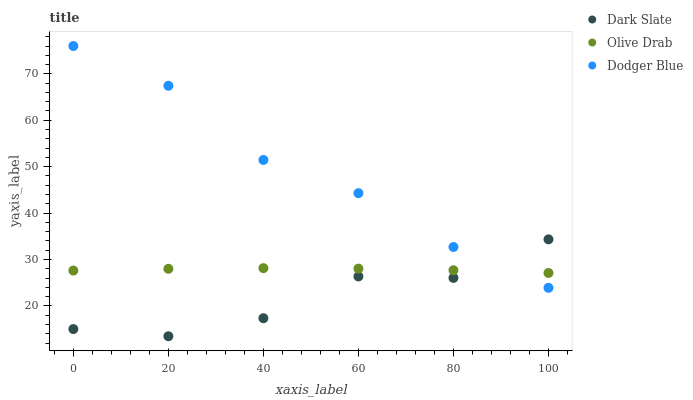Does Dark Slate have the minimum area under the curve?
Answer yes or no. Yes. Does Dodger Blue have the maximum area under the curve?
Answer yes or no. Yes. Does Olive Drab have the minimum area under the curve?
Answer yes or no. No. Does Olive Drab have the maximum area under the curve?
Answer yes or no. No. Is Olive Drab the smoothest?
Answer yes or no. Yes. Is Dark Slate the roughest?
Answer yes or no. Yes. Is Dodger Blue the smoothest?
Answer yes or no. No. Is Dodger Blue the roughest?
Answer yes or no. No. Does Dark Slate have the lowest value?
Answer yes or no. Yes. Does Dodger Blue have the lowest value?
Answer yes or no. No. Does Dodger Blue have the highest value?
Answer yes or no. Yes. Does Olive Drab have the highest value?
Answer yes or no. No. Does Olive Drab intersect Dark Slate?
Answer yes or no. Yes. Is Olive Drab less than Dark Slate?
Answer yes or no. No. Is Olive Drab greater than Dark Slate?
Answer yes or no. No. 